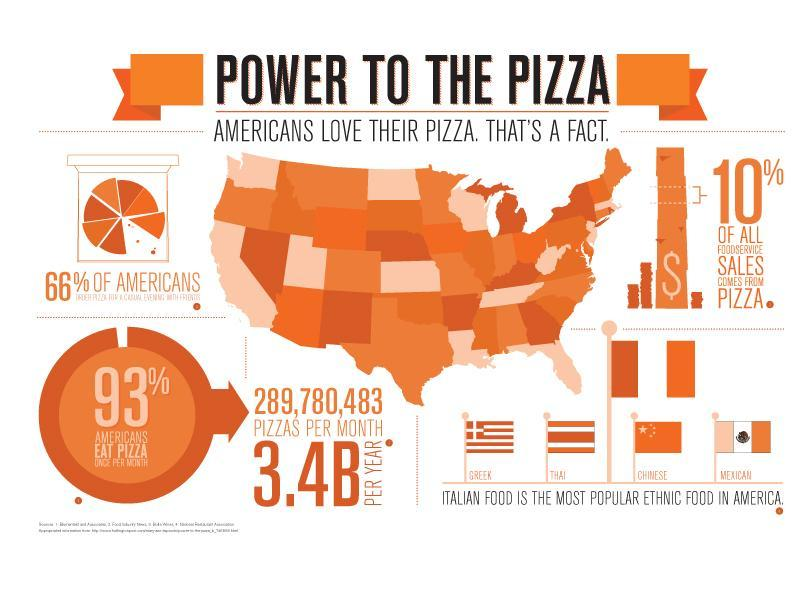What is the percentage of food service sales in america that comes from pizza?
Answer the question with a short phrase. 10% What is the percentage of food service sales in america that  do not come from pizza? 90% What is the estimated amount of pizzas consumed by Americans per year? 3.4B PER YEAR Which italian food the Americans love the most? PIZZA What percent of Americans do not eat Pizza atleast once in a month? 7% What is the estimated amount of pizzas consumed by americans per month? 289,780,483 pizzas per month What percent of Americans eat Pizza once per month? 93% 